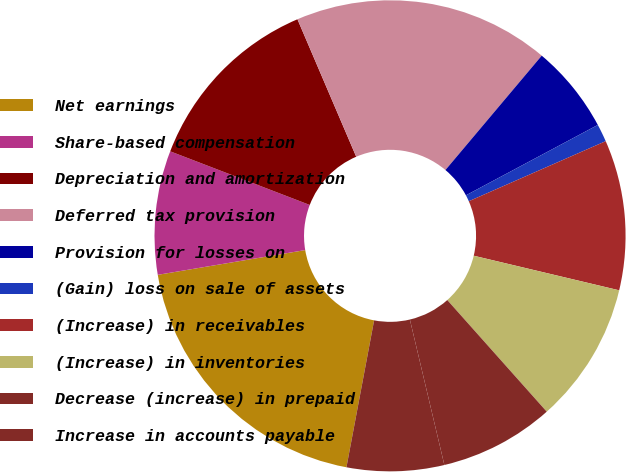Convert chart. <chart><loc_0><loc_0><loc_500><loc_500><pie_chart><fcel>Net earnings<fcel>Share-based compensation<fcel>Depreciation and amortization<fcel>Deferred tax provision<fcel>Provision for losses on<fcel>(Gain) loss on sale of assets<fcel>(Increase) in receivables<fcel>(Increase) in inventories<fcel>Decrease (increase) in prepaid<fcel>Increase in accounts payable<nl><fcel>19.39%<fcel>8.49%<fcel>12.73%<fcel>17.57%<fcel>6.06%<fcel>1.22%<fcel>10.3%<fcel>9.7%<fcel>7.88%<fcel>6.67%<nl></chart> 